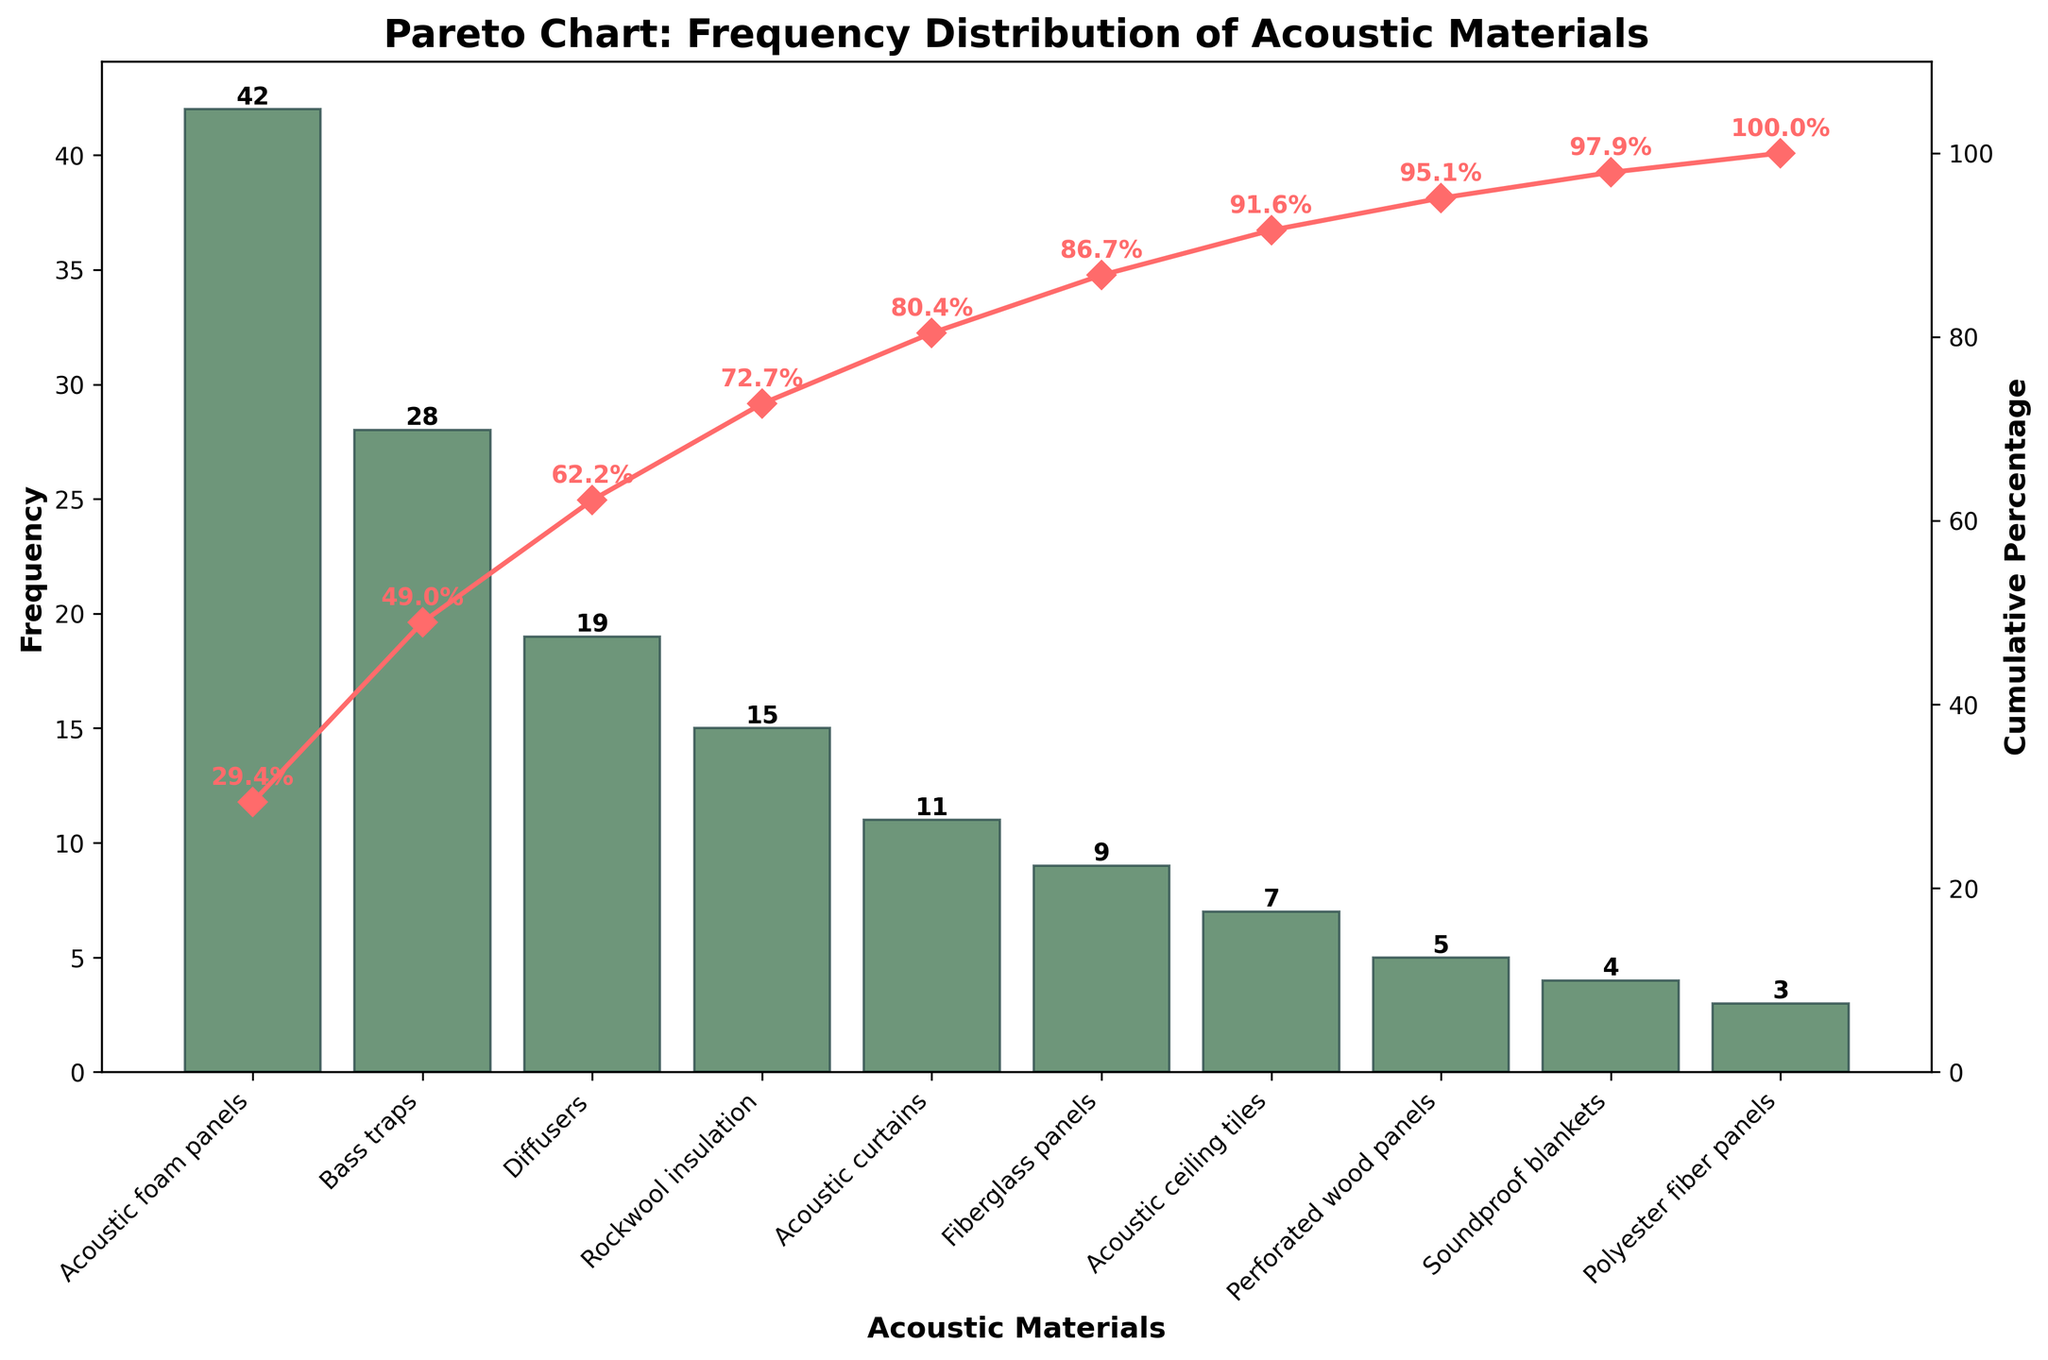What is the total number of different acoustic materials represented in the chart? Count the number of unique acoustic materials listed on the x-axis. There are 10 bars, each representing a different material.
Answer: 10 Which acoustic material has the highest frequency and what is its value? Identify the tallest bar on the chart and read its associated material and frequency. The tallest bar represents "Acoustic foam panels" with a frequency of 42.
Answer: Acoustic foam panels, 42 What percentage of the total frequency does the most used acoustic material contribute? The cumulative percentage for "Acoustic foam panels" should indicate its contribution relative to the total. The chart shows "Acoustic foam panels" have a frequency of 42, which is calculated as (42/143) * 100%.
Answer: 29.4% How many acoustic materials cumulatively account for at least 80% of the usage? Examine the cumulative percentage line until it reaches or exceeds 80%. The first four materials ("Acoustic foam panels," "Bass traps," "Diffusers," and "Rockwool insulation") have cumulative percentages of 29.4%, 49.0%, 62.3%, and 72.8%, respectively. Adding the next material ("Acoustic curtains") brings it to 80.5%. Thus, five materials in total.
Answer: 5 What is the combined frequency of the three least used acoustic materials? Add the frequencies of the three least used materials shown at the far right: "Soundproof blankets" (4), "Polyester fiber panels" (3), and "Perforated wood panels" (5). Total is 4 + 3 + 5 = 12.
Answer: 12 What is the difference in frequency between "Bass traps" and "Acoustic curtains"? Subtract the frequency of "Acoustic curtains" (11) from that of "Bass traps" (28): 28 - 11 = 17.
Answer: 17 What cumulative percentage is reached after including "Rockwool insulation"? Look at the cumulative percentage line, noting the percentage value at "Rockwool insulation". The cumulative percentage for "Rockwool insulation" is 72.8%.
Answer: 72.8% What is the frequency range of the materials shown in the chart? Subtract the frequency of the least used material "Polyester fiber panels" (3) from that of the most used material "Acoustic foam panels" (42): 42 - 3 = 39.
Answer: 39 Which two materials have the closest frequencies, and what are those values? Compare the bars with similar heights and verify their frequencies. "Fiberglass panels" and "Acoustic ceiling tiles" have frequencies 9 and 7 respectively, meaning the difference is only 2, which is smaller than other differences.
Answer: Fiberglass panels (9) and Acoustic ceiling tiles (7) What trends can you observe in the use of acoustic materials? Analyze the pattern in the chart. The data shows that the usage of acoustic materials rapidly decreases after the first few items, and a few materials make up the majority of the usage, indicating a preference for certain materials. The cumulative percentage line sharply rises initially and then plateaus.
Answer: Few materials dominate usage 